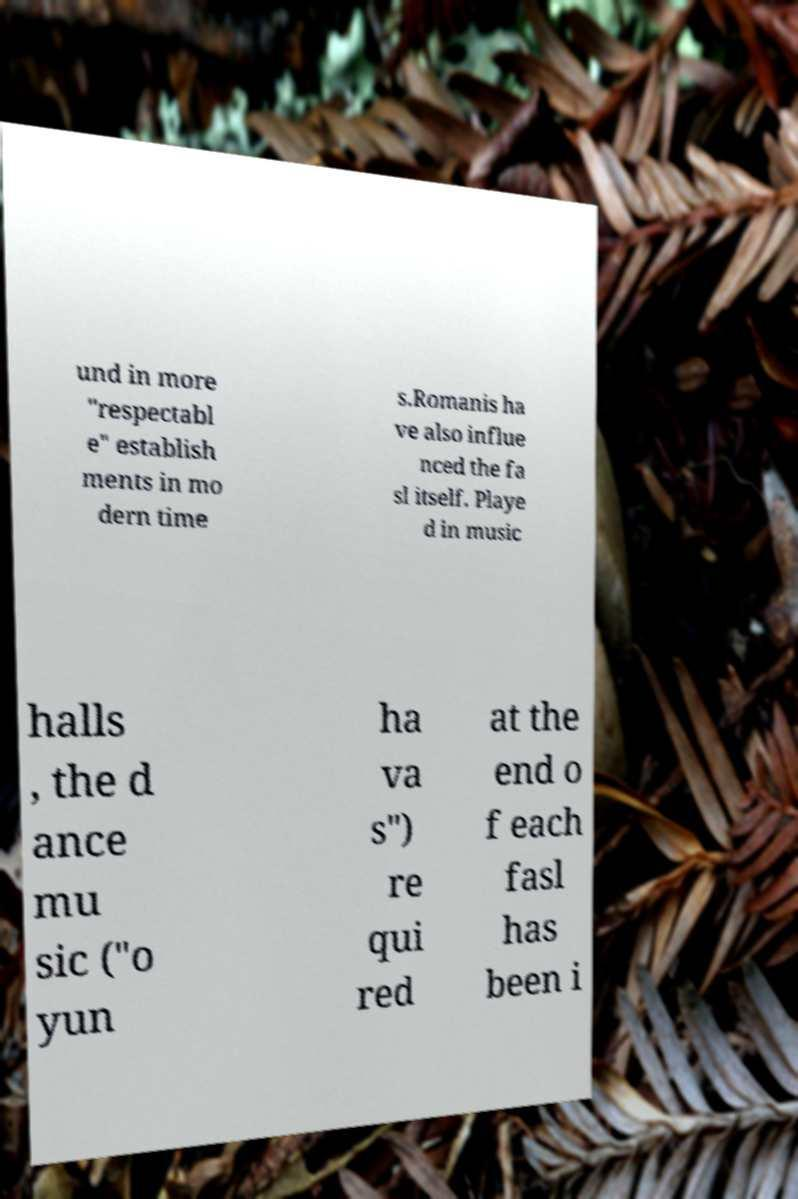Please identify and transcribe the text found in this image. und in more "respectabl e" establish ments in mo dern time s.Romanis ha ve also influe nced the fa sl itself. Playe d in music halls , the d ance mu sic ("o yun ha va s") re qui red at the end o f each fasl has been i 